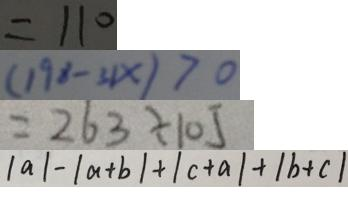<formula> <loc_0><loc_0><loc_500><loc_500>= 1 1 0 
 ( 1 9 8 - 3 1 x ) > 0 
 = 2 6 3 \div 1 0 5 
 \vert a \vert - \vert a + b \vert + \vert c + a \vert + \vert b + c \vert</formula> 